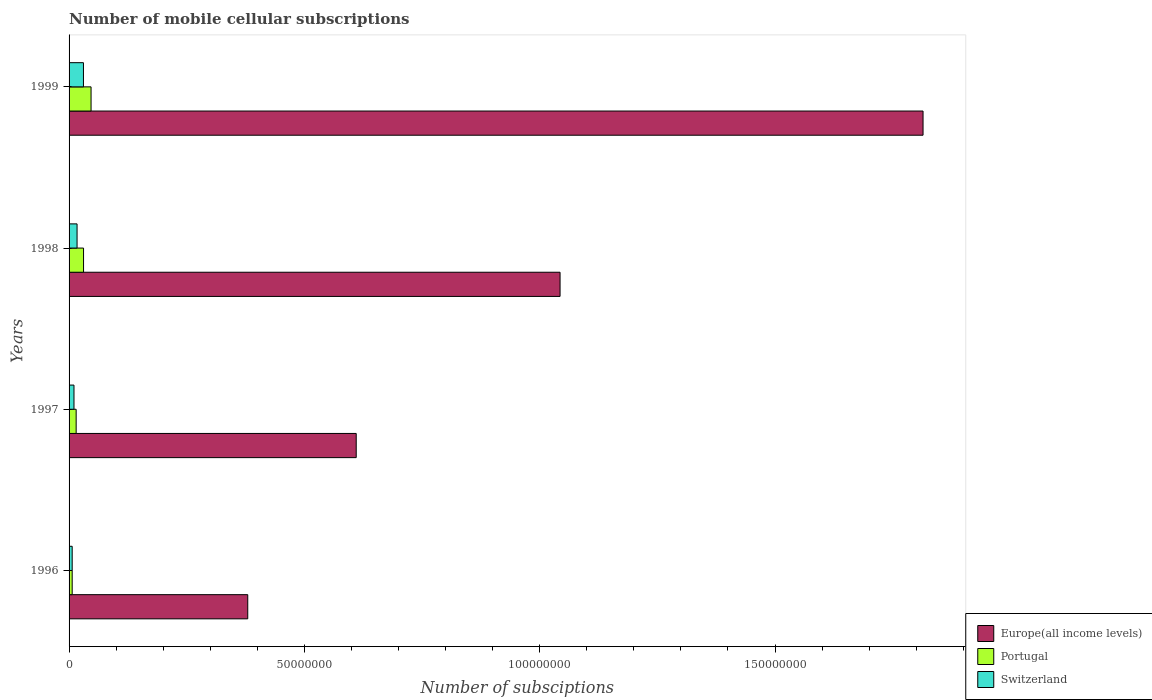How many groups of bars are there?
Make the answer very short. 4. What is the label of the 1st group of bars from the top?
Provide a short and direct response. 1999. What is the number of mobile cellular subscriptions in Europe(all income levels) in 1997?
Your response must be concise. 6.10e+07. Across all years, what is the maximum number of mobile cellular subscriptions in Switzerland?
Provide a short and direct response. 3.06e+06. Across all years, what is the minimum number of mobile cellular subscriptions in Europe(all income levels)?
Provide a succinct answer. 3.80e+07. What is the total number of mobile cellular subscriptions in Portugal in the graph?
Offer a terse response. 9.92e+06. What is the difference between the number of mobile cellular subscriptions in Europe(all income levels) in 1996 and that in 1997?
Ensure brevity in your answer.  -2.30e+07. What is the difference between the number of mobile cellular subscriptions in Switzerland in 1998 and the number of mobile cellular subscriptions in Europe(all income levels) in 1999?
Keep it short and to the point. -1.80e+08. What is the average number of mobile cellular subscriptions in Switzerland per year?
Make the answer very short. 1.62e+06. In the year 1997, what is the difference between the number of mobile cellular subscriptions in Switzerland and number of mobile cellular subscriptions in Europe(all income levels)?
Give a very brief answer. -6.00e+07. What is the ratio of the number of mobile cellular subscriptions in Switzerland in 1996 to that in 1997?
Ensure brevity in your answer.  0.63. Is the number of mobile cellular subscriptions in Portugal in 1997 less than that in 1998?
Your answer should be compact. Yes. What is the difference between the highest and the second highest number of mobile cellular subscriptions in Portugal?
Keep it short and to the point. 1.60e+06. What is the difference between the highest and the lowest number of mobile cellular subscriptions in Portugal?
Make the answer very short. 4.01e+06. In how many years, is the number of mobile cellular subscriptions in Europe(all income levels) greater than the average number of mobile cellular subscriptions in Europe(all income levels) taken over all years?
Offer a very short reply. 2. Is the sum of the number of mobile cellular subscriptions in Switzerland in 1997 and 1999 greater than the maximum number of mobile cellular subscriptions in Europe(all income levels) across all years?
Keep it short and to the point. No. What does the 1st bar from the top in 1998 represents?
Provide a short and direct response. Switzerland. What does the 1st bar from the bottom in 1999 represents?
Offer a very short reply. Europe(all income levels). Are all the bars in the graph horizontal?
Provide a succinct answer. Yes. How many years are there in the graph?
Make the answer very short. 4. What is the difference between two consecutive major ticks on the X-axis?
Give a very brief answer. 5.00e+07. Where does the legend appear in the graph?
Offer a very short reply. Bottom right. How many legend labels are there?
Ensure brevity in your answer.  3. How are the legend labels stacked?
Your response must be concise. Vertical. What is the title of the graph?
Offer a very short reply. Number of mobile cellular subscriptions. What is the label or title of the X-axis?
Your response must be concise. Number of subsciptions. What is the Number of subsciptions in Europe(all income levels) in 1996?
Make the answer very short. 3.80e+07. What is the Number of subsciptions of Portugal in 1996?
Offer a very short reply. 6.64e+05. What is the Number of subsciptions in Switzerland in 1996?
Keep it short and to the point. 6.63e+05. What is the Number of subsciptions of Europe(all income levels) in 1997?
Your answer should be very brief. 6.10e+07. What is the Number of subsciptions of Portugal in 1997?
Your response must be concise. 1.51e+06. What is the Number of subsciptions of Switzerland in 1997?
Your answer should be compact. 1.04e+06. What is the Number of subsciptions of Europe(all income levels) in 1998?
Your response must be concise. 1.04e+08. What is the Number of subsciptions of Portugal in 1998?
Offer a very short reply. 3.07e+06. What is the Number of subsciptions in Switzerland in 1998?
Offer a very short reply. 1.70e+06. What is the Number of subsciptions of Europe(all income levels) in 1999?
Make the answer very short. 1.81e+08. What is the Number of subsciptions of Portugal in 1999?
Your answer should be compact. 4.67e+06. What is the Number of subsciptions of Switzerland in 1999?
Ensure brevity in your answer.  3.06e+06. Across all years, what is the maximum Number of subsciptions in Europe(all income levels)?
Offer a terse response. 1.81e+08. Across all years, what is the maximum Number of subsciptions of Portugal?
Keep it short and to the point. 4.67e+06. Across all years, what is the maximum Number of subsciptions in Switzerland?
Your response must be concise. 3.06e+06. Across all years, what is the minimum Number of subsciptions in Europe(all income levels)?
Ensure brevity in your answer.  3.80e+07. Across all years, what is the minimum Number of subsciptions in Portugal?
Offer a terse response. 6.64e+05. Across all years, what is the minimum Number of subsciptions in Switzerland?
Offer a terse response. 6.63e+05. What is the total Number of subsciptions of Europe(all income levels) in the graph?
Offer a very short reply. 3.85e+08. What is the total Number of subsciptions in Portugal in the graph?
Ensure brevity in your answer.  9.92e+06. What is the total Number of subsciptions of Switzerland in the graph?
Provide a succinct answer. 6.46e+06. What is the difference between the Number of subsciptions of Europe(all income levels) in 1996 and that in 1997?
Offer a very short reply. -2.30e+07. What is the difference between the Number of subsciptions of Portugal in 1996 and that in 1997?
Your answer should be compact. -8.43e+05. What is the difference between the Number of subsciptions of Switzerland in 1996 and that in 1997?
Provide a short and direct response. -3.82e+05. What is the difference between the Number of subsciptions in Europe(all income levels) in 1996 and that in 1998?
Offer a terse response. -6.64e+07. What is the difference between the Number of subsciptions in Portugal in 1996 and that in 1998?
Your response must be concise. -2.41e+06. What is the difference between the Number of subsciptions in Switzerland in 1996 and that in 1998?
Make the answer very short. -1.04e+06. What is the difference between the Number of subsciptions in Europe(all income levels) in 1996 and that in 1999?
Your answer should be very brief. -1.43e+08. What is the difference between the Number of subsciptions of Portugal in 1996 and that in 1999?
Provide a short and direct response. -4.01e+06. What is the difference between the Number of subsciptions in Switzerland in 1996 and that in 1999?
Offer a very short reply. -2.39e+06. What is the difference between the Number of subsciptions in Europe(all income levels) in 1997 and that in 1998?
Ensure brevity in your answer.  -4.33e+07. What is the difference between the Number of subsciptions in Portugal in 1997 and that in 1998?
Your answer should be compact. -1.57e+06. What is the difference between the Number of subsciptions in Switzerland in 1997 and that in 1998?
Your answer should be compact. -6.54e+05. What is the difference between the Number of subsciptions of Europe(all income levels) in 1997 and that in 1999?
Your answer should be compact. -1.20e+08. What is the difference between the Number of subsciptions in Portugal in 1997 and that in 1999?
Provide a succinct answer. -3.16e+06. What is the difference between the Number of subsciptions of Switzerland in 1997 and that in 1999?
Make the answer very short. -2.01e+06. What is the difference between the Number of subsciptions in Europe(all income levels) in 1998 and that in 1999?
Give a very brief answer. -7.71e+07. What is the difference between the Number of subsciptions in Portugal in 1998 and that in 1999?
Make the answer very short. -1.60e+06. What is the difference between the Number of subsciptions of Switzerland in 1998 and that in 1999?
Your response must be concise. -1.36e+06. What is the difference between the Number of subsciptions in Europe(all income levels) in 1996 and the Number of subsciptions in Portugal in 1997?
Give a very brief answer. 3.65e+07. What is the difference between the Number of subsciptions in Europe(all income levels) in 1996 and the Number of subsciptions in Switzerland in 1997?
Provide a short and direct response. 3.69e+07. What is the difference between the Number of subsciptions of Portugal in 1996 and the Number of subsciptions of Switzerland in 1997?
Keep it short and to the point. -3.81e+05. What is the difference between the Number of subsciptions of Europe(all income levels) in 1996 and the Number of subsciptions of Portugal in 1998?
Ensure brevity in your answer.  3.49e+07. What is the difference between the Number of subsciptions of Europe(all income levels) in 1996 and the Number of subsciptions of Switzerland in 1998?
Your answer should be compact. 3.63e+07. What is the difference between the Number of subsciptions in Portugal in 1996 and the Number of subsciptions in Switzerland in 1998?
Offer a terse response. -1.03e+06. What is the difference between the Number of subsciptions of Europe(all income levels) in 1996 and the Number of subsciptions of Portugal in 1999?
Your answer should be very brief. 3.33e+07. What is the difference between the Number of subsciptions of Europe(all income levels) in 1996 and the Number of subsciptions of Switzerland in 1999?
Provide a succinct answer. 3.49e+07. What is the difference between the Number of subsciptions in Portugal in 1996 and the Number of subsciptions in Switzerland in 1999?
Keep it short and to the point. -2.39e+06. What is the difference between the Number of subsciptions of Europe(all income levels) in 1997 and the Number of subsciptions of Portugal in 1998?
Offer a terse response. 5.79e+07. What is the difference between the Number of subsciptions in Europe(all income levels) in 1997 and the Number of subsciptions in Switzerland in 1998?
Your response must be concise. 5.93e+07. What is the difference between the Number of subsciptions of Portugal in 1997 and the Number of subsciptions of Switzerland in 1998?
Keep it short and to the point. -1.92e+05. What is the difference between the Number of subsciptions of Europe(all income levels) in 1997 and the Number of subsciptions of Portugal in 1999?
Provide a succinct answer. 5.63e+07. What is the difference between the Number of subsciptions in Europe(all income levels) in 1997 and the Number of subsciptions in Switzerland in 1999?
Make the answer very short. 5.80e+07. What is the difference between the Number of subsciptions in Portugal in 1997 and the Number of subsciptions in Switzerland in 1999?
Your response must be concise. -1.55e+06. What is the difference between the Number of subsciptions in Europe(all income levels) in 1998 and the Number of subsciptions in Portugal in 1999?
Keep it short and to the point. 9.97e+07. What is the difference between the Number of subsciptions in Europe(all income levels) in 1998 and the Number of subsciptions in Switzerland in 1999?
Ensure brevity in your answer.  1.01e+08. What is the difference between the Number of subsciptions of Portugal in 1998 and the Number of subsciptions of Switzerland in 1999?
Give a very brief answer. 1.71e+04. What is the average Number of subsciptions of Europe(all income levels) per year?
Provide a succinct answer. 9.62e+07. What is the average Number of subsciptions in Portugal per year?
Ensure brevity in your answer.  2.48e+06. What is the average Number of subsciptions in Switzerland per year?
Make the answer very short. 1.62e+06. In the year 1996, what is the difference between the Number of subsciptions in Europe(all income levels) and Number of subsciptions in Portugal?
Provide a short and direct response. 3.73e+07. In the year 1996, what is the difference between the Number of subsciptions of Europe(all income levels) and Number of subsciptions of Switzerland?
Keep it short and to the point. 3.73e+07. In the year 1996, what is the difference between the Number of subsciptions of Portugal and Number of subsciptions of Switzerland?
Offer a very short reply. 938. In the year 1997, what is the difference between the Number of subsciptions of Europe(all income levels) and Number of subsciptions of Portugal?
Make the answer very short. 5.95e+07. In the year 1997, what is the difference between the Number of subsciptions in Europe(all income levels) and Number of subsciptions in Switzerland?
Keep it short and to the point. 6.00e+07. In the year 1997, what is the difference between the Number of subsciptions of Portugal and Number of subsciptions of Switzerland?
Your answer should be very brief. 4.63e+05. In the year 1998, what is the difference between the Number of subsciptions of Europe(all income levels) and Number of subsciptions of Portugal?
Make the answer very short. 1.01e+08. In the year 1998, what is the difference between the Number of subsciptions of Europe(all income levels) and Number of subsciptions of Switzerland?
Offer a terse response. 1.03e+08. In the year 1998, what is the difference between the Number of subsciptions of Portugal and Number of subsciptions of Switzerland?
Ensure brevity in your answer.  1.38e+06. In the year 1999, what is the difference between the Number of subsciptions of Europe(all income levels) and Number of subsciptions of Portugal?
Offer a very short reply. 1.77e+08. In the year 1999, what is the difference between the Number of subsciptions of Europe(all income levels) and Number of subsciptions of Switzerland?
Your response must be concise. 1.78e+08. In the year 1999, what is the difference between the Number of subsciptions of Portugal and Number of subsciptions of Switzerland?
Provide a short and direct response. 1.61e+06. What is the ratio of the Number of subsciptions of Europe(all income levels) in 1996 to that in 1997?
Offer a terse response. 0.62. What is the ratio of the Number of subsciptions of Portugal in 1996 to that in 1997?
Your response must be concise. 0.44. What is the ratio of the Number of subsciptions of Switzerland in 1996 to that in 1997?
Your answer should be compact. 0.63. What is the ratio of the Number of subsciptions of Europe(all income levels) in 1996 to that in 1998?
Your answer should be compact. 0.36. What is the ratio of the Number of subsciptions of Portugal in 1996 to that in 1998?
Offer a very short reply. 0.22. What is the ratio of the Number of subsciptions in Switzerland in 1996 to that in 1998?
Give a very brief answer. 0.39. What is the ratio of the Number of subsciptions of Europe(all income levels) in 1996 to that in 1999?
Provide a short and direct response. 0.21. What is the ratio of the Number of subsciptions of Portugal in 1996 to that in 1999?
Ensure brevity in your answer.  0.14. What is the ratio of the Number of subsciptions in Switzerland in 1996 to that in 1999?
Give a very brief answer. 0.22. What is the ratio of the Number of subsciptions of Europe(all income levels) in 1997 to that in 1998?
Your answer should be compact. 0.58. What is the ratio of the Number of subsciptions of Portugal in 1997 to that in 1998?
Ensure brevity in your answer.  0.49. What is the ratio of the Number of subsciptions of Switzerland in 1997 to that in 1998?
Offer a very short reply. 0.61. What is the ratio of the Number of subsciptions of Europe(all income levels) in 1997 to that in 1999?
Give a very brief answer. 0.34. What is the ratio of the Number of subsciptions in Portugal in 1997 to that in 1999?
Your response must be concise. 0.32. What is the ratio of the Number of subsciptions of Switzerland in 1997 to that in 1999?
Offer a terse response. 0.34. What is the ratio of the Number of subsciptions of Europe(all income levels) in 1998 to that in 1999?
Your response must be concise. 0.57. What is the ratio of the Number of subsciptions of Portugal in 1998 to that in 1999?
Your answer should be compact. 0.66. What is the ratio of the Number of subsciptions in Switzerland in 1998 to that in 1999?
Make the answer very short. 0.56. What is the difference between the highest and the second highest Number of subsciptions of Europe(all income levels)?
Provide a succinct answer. 7.71e+07. What is the difference between the highest and the second highest Number of subsciptions of Portugal?
Keep it short and to the point. 1.60e+06. What is the difference between the highest and the second highest Number of subsciptions in Switzerland?
Offer a very short reply. 1.36e+06. What is the difference between the highest and the lowest Number of subsciptions of Europe(all income levels)?
Offer a very short reply. 1.43e+08. What is the difference between the highest and the lowest Number of subsciptions in Portugal?
Your response must be concise. 4.01e+06. What is the difference between the highest and the lowest Number of subsciptions of Switzerland?
Your answer should be very brief. 2.39e+06. 